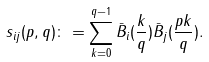<formula> <loc_0><loc_0><loc_500><loc_500>s _ { i j } ( p , q ) \colon = \sum _ { k = 0 } ^ { q - 1 } \bar { B } _ { i } ( \frac { k } { q } ) \bar { B } _ { j } ( \frac { p k } { q } ) .</formula> 